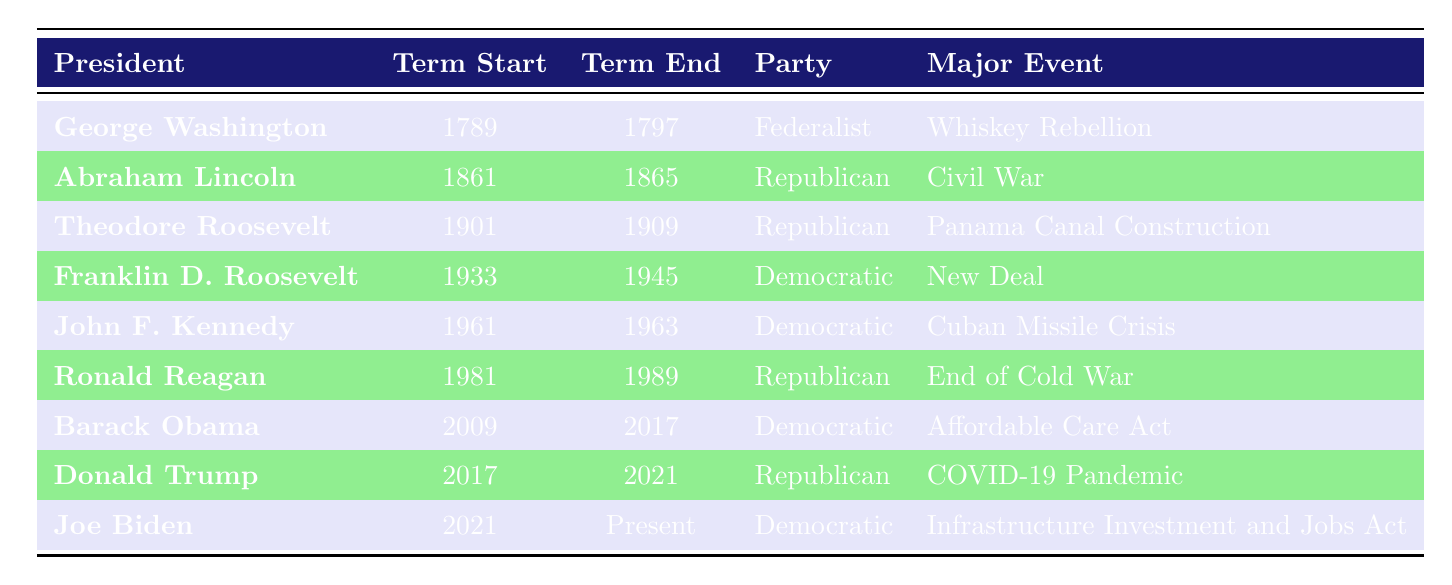What was the term end year for Franklin D. Roosevelt? According to the table, Franklin D. Roosevelt's term ended in 1945.
Answer: 1945 Which political party did Abraham Lincoln belong to? The table indicates that Abraham Lincoln was a member of the Republican party.
Answer: Republican What were the terms of office for Ronald Reagan? The table shows that Ronald Reagan's term started in 1981 and ended in 1989.
Answer: 1981 to 1989 How many presidents served during the 20th century? The relevant presidents in the table who served in the 20th century are Theodore Roosevelt, Franklin D. Roosevelt, John F. Kennedy, and Ronald Reagan. Therefore, there are 4 presidents who served during that time.
Answer: 4 Did Barack Obama serve before Donald Trump? The table indicates Barack Obama's term started in 2009 and ended in 2017, while Donald Trump's term started in 2017 and ended in 2021. Thus, yes, Barack Obama served before Donald Trump.
Answer: Yes What was the total number of Democratic presidents listed in the table? The table includes Franklin D. Roosevelt, John F. Kennedy, Barack Obama, and Joe Biden as Democratic presidents. Counting these, we find there are 4 Democratic presidents.
Answer: 4 Which president had the major event of the Cuban Missile Crisis? Looking at the table, John F. Kennedy is listed as the president associated with the Cuban Missile Crisis.
Answer: John F. Kennedy What is the difference in years between the term end of George Washington and the term end of Joe Biden? George Washington's term ended in 1797 and Joe Biden's term is ongoing (2023). The difference in years is 2023 - 1797 = 226 years.
Answer: 226 years Which president had the longest term in office according to the table? Franklin D. Roosevelt's term lasted from 1933 to 1945, which is the longest duration listed (12 years). Therefore, Franklin D. Roosevelt had the longest term in office.
Answer: Franklin D. Roosevelt 